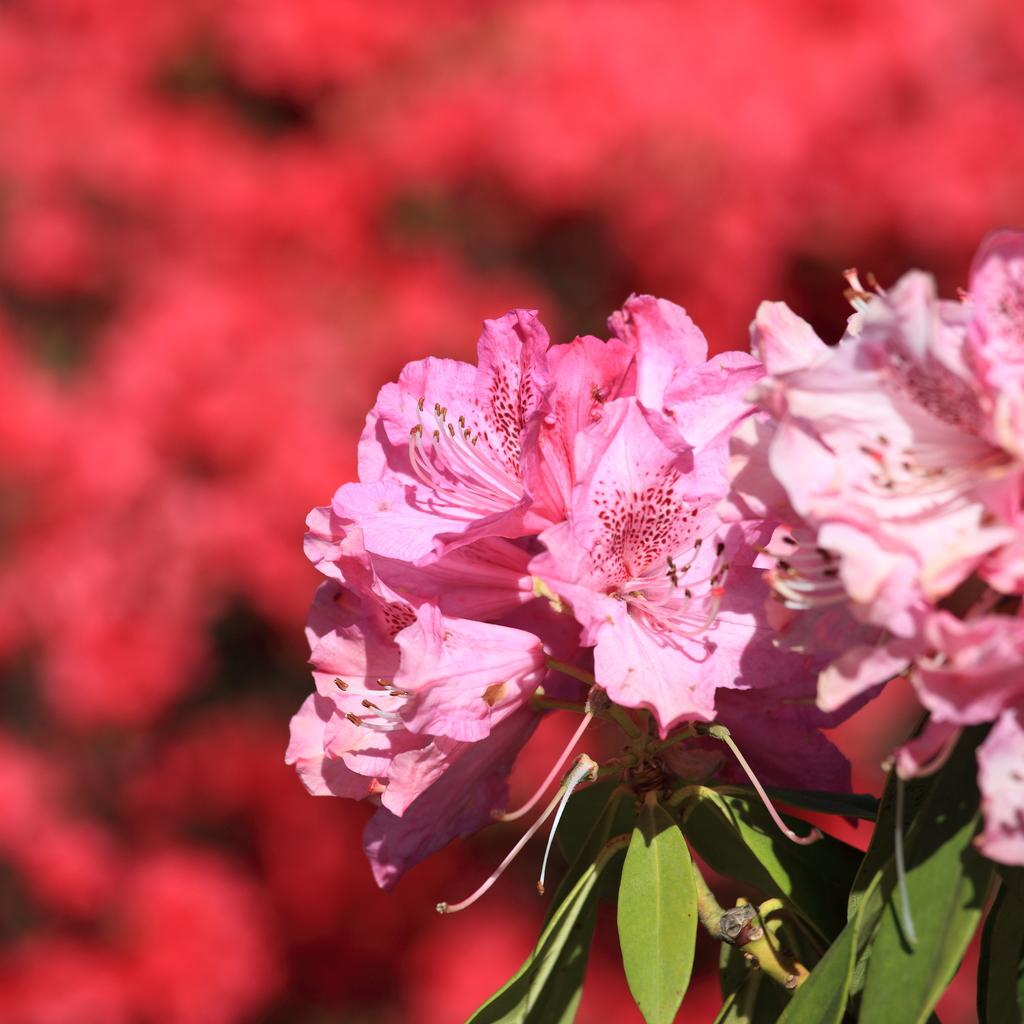What type of flowers can be seen on the right side of the image? There are pink flowers on the right side of the image. What is the relationship between the flowers and the tree? The flowers are part of a tree. What color are the leaves of the tree? The tree has green leaves. Can you describe the background of the image? The background of the image is blurred. How many parcels can be seen falling from the sky in the image? There are no parcels present in the image, and therefore none can be seen falling from the sky. 